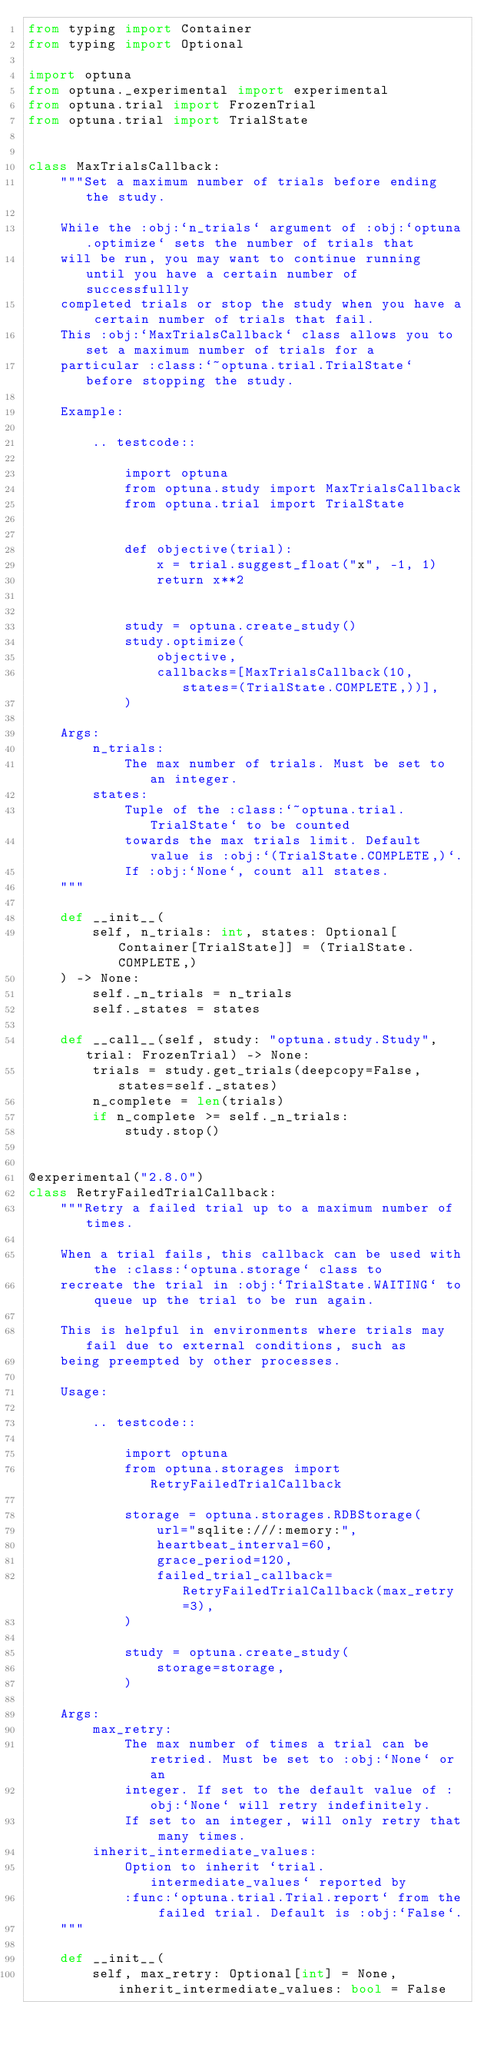Convert code to text. <code><loc_0><loc_0><loc_500><loc_500><_Python_>from typing import Container
from typing import Optional

import optuna
from optuna._experimental import experimental
from optuna.trial import FrozenTrial
from optuna.trial import TrialState


class MaxTrialsCallback:
    """Set a maximum number of trials before ending the study.

    While the :obj:`n_trials` argument of :obj:`optuna.optimize` sets the number of trials that
    will be run, you may want to continue running until you have a certain number of successfullly
    completed trials or stop the study when you have a certain number of trials that fail.
    This :obj:`MaxTrialsCallback` class allows you to set a maximum number of trials for a
    particular :class:`~optuna.trial.TrialState` before stopping the study.

    Example:

        .. testcode::

            import optuna
            from optuna.study import MaxTrialsCallback
            from optuna.trial import TrialState


            def objective(trial):
                x = trial.suggest_float("x", -1, 1)
                return x**2


            study = optuna.create_study()
            study.optimize(
                objective,
                callbacks=[MaxTrialsCallback(10, states=(TrialState.COMPLETE,))],
            )

    Args:
        n_trials:
            The max number of trials. Must be set to an integer.
        states:
            Tuple of the :class:`~optuna.trial.TrialState` to be counted
            towards the max trials limit. Default value is :obj:`(TrialState.COMPLETE,)`.
            If :obj:`None`, count all states.
    """

    def __init__(
        self, n_trials: int, states: Optional[Container[TrialState]] = (TrialState.COMPLETE,)
    ) -> None:
        self._n_trials = n_trials
        self._states = states

    def __call__(self, study: "optuna.study.Study", trial: FrozenTrial) -> None:
        trials = study.get_trials(deepcopy=False, states=self._states)
        n_complete = len(trials)
        if n_complete >= self._n_trials:
            study.stop()


@experimental("2.8.0")
class RetryFailedTrialCallback:
    """Retry a failed trial up to a maximum number of times.

    When a trial fails, this callback can be used with the :class:`optuna.storage` class to
    recreate the trial in :obj:`TrialState.WAITING` to queue up the trial to be run again.

    This is helpful in environments where trials may fail due to external conditions, such as
    being preempted by other processes.

    Usage:

        .. testcode::

            import optuna
            from optuna.storages import RetryFailedTrialCallback

            storage = optuna.storages.RDBStorage(
                url="sqlite:///:memory:",
                heartbeat_interval=60,
                grace_period=120,
                failed_trial_callback=RetryFailedTrialCallback(max_retry=3),
            )

            study = optuna.create_study(
                storage=storage,
            )

    Args:
        max_retry:
            The max number of times a trial can be retried. Must be set to :obj:`None` or an
            integer. If set to the default value of :obj:`None` will retry indefinitely.
            If set to an integer, will only retry that many times.
        inherit_intermediate_values:
            Option to inherit `trial.intermediate_values` reported by
            :func:`optuna.trial.Trial.report` from the failed trial. Default is :obj:`False`.
    """

    def __init__(
        self, max_retry: Optional[int] = None, inherit_intermediate_values: bool = False</code> 